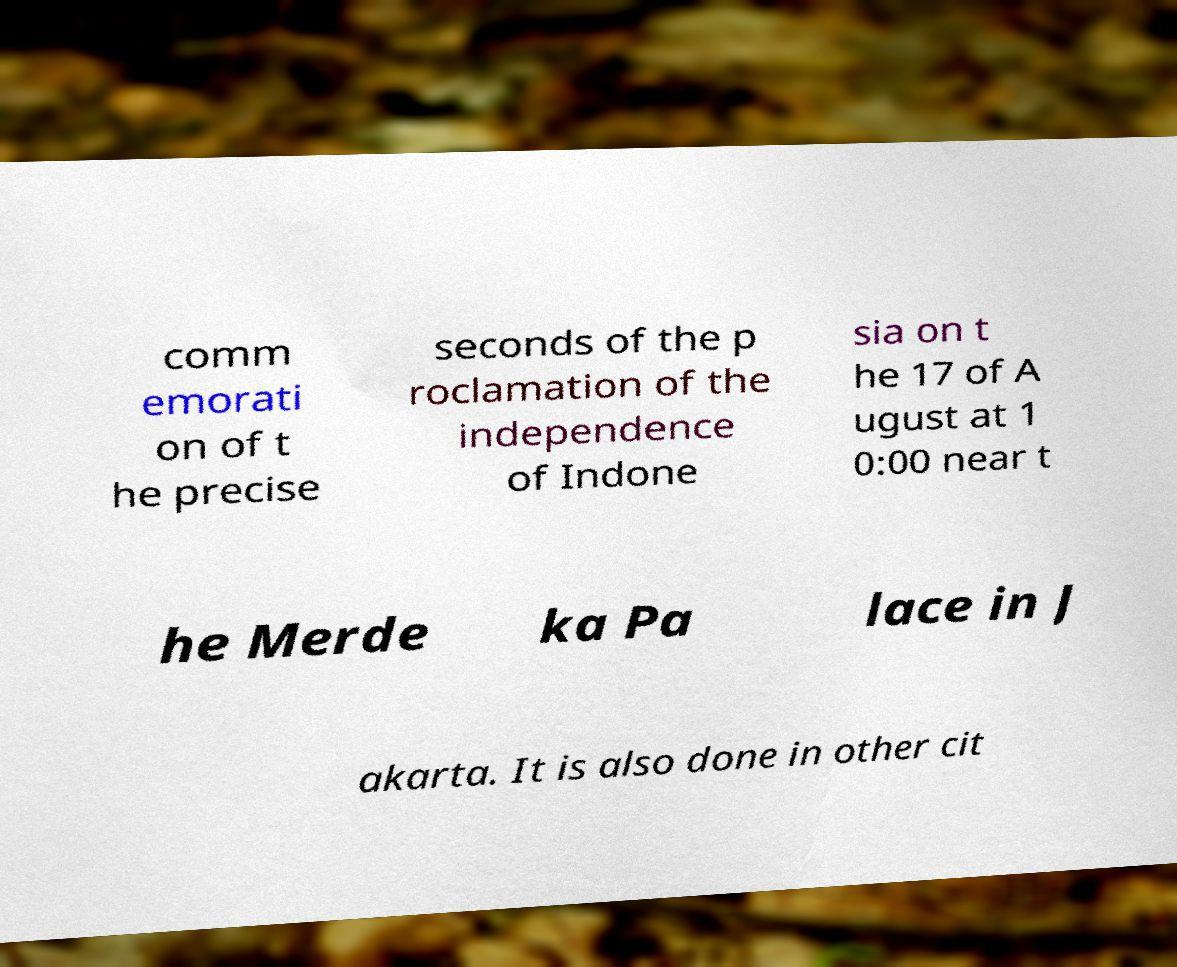Could you extract and type out the text from this image? comm emorati on of t he precise seconds of the p roclamation of the independence of Indone sia on t he 17 of A ugust at 1 0:00 near t he Merde ka Pa lace in J akarta. It is also done in other cit 